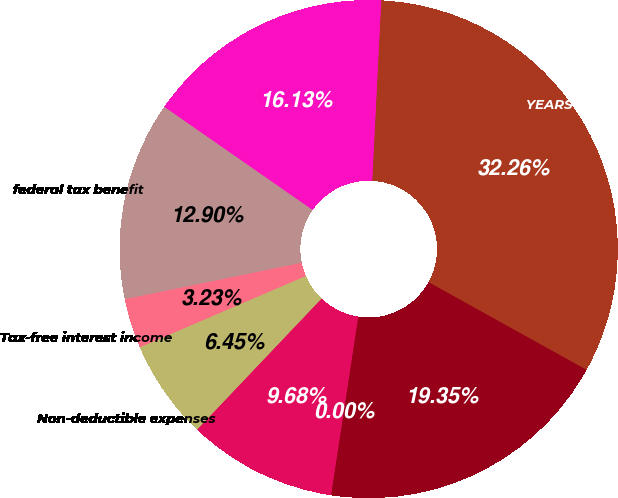<chart> <loc_0><loc_0><loc_500><loc_500><pie_chart><fcel>YEARS ENDED DECEMBER 31<fcel>Federal US income tax rate<fcel>federal tax benefit<fcel>Tax-free interest income<fcel>Non-deductible expenses<fcel>Non-US income taxed at<fcel>Other net<fcel>Effective tax rate<nl><fcel>32.26%<fcel>16.13%<fcel>12.9%<fcel>3.23%<fcel>6.45%<fcel>9.68%<fcel>0.0%<fcel>19.35%<nl></chart> 